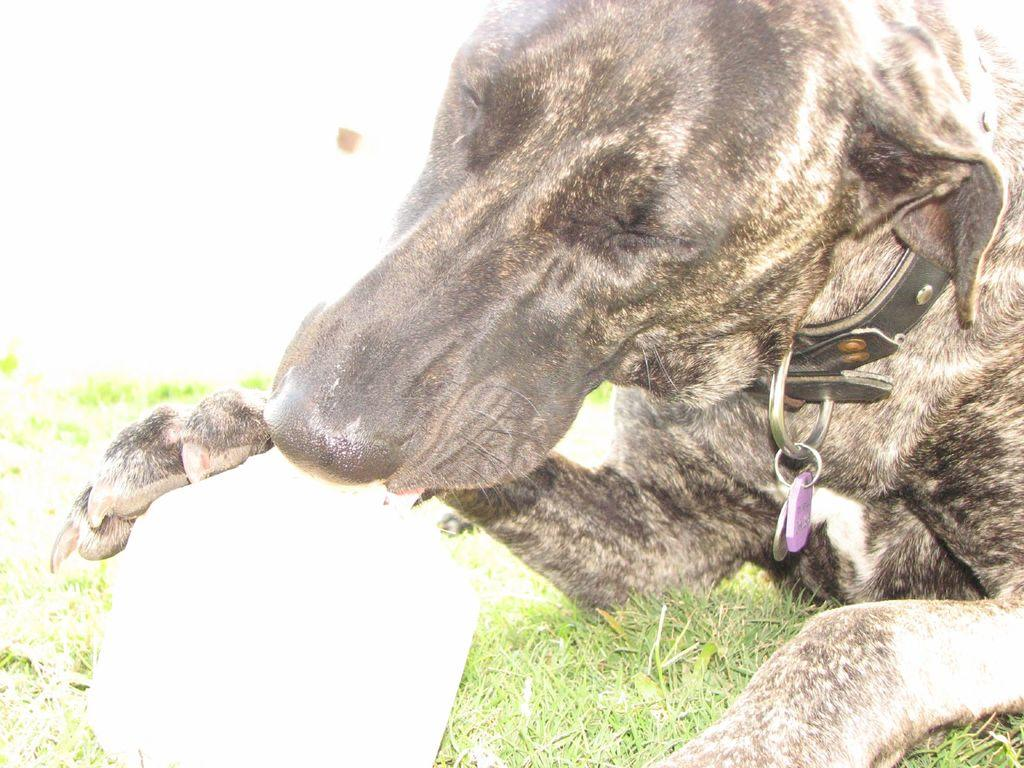What type of animal is in the picture? There is a black color dog in the picture. Is the dog wearing anything in the picture? Yes, the dog is wearing a collar neck belt. What can be seen on the left side of the picture? There is grass and a white color object on the left side of the picture. What type of trousers is the dog wearing in the picture? The dog is not wearing trousers in the picture; it is wearing a collar neck belt. Can you tell me how many units of quartz are visible in the picture? There is no quartz present in the picture. 